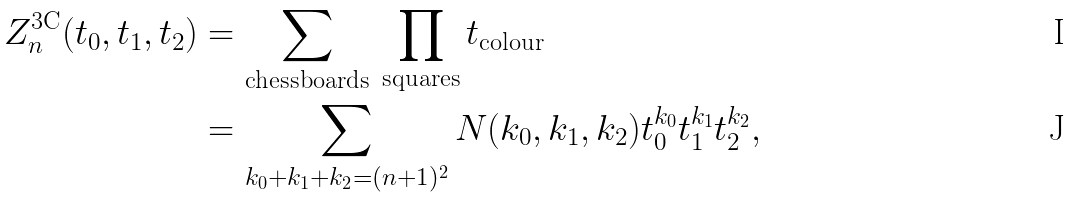<formula> <loc_0><loc_0><loc_500><loc_500>Z _ { n } ^ { \text {3C} } ( t _ { 0 } , t _ { 1 } , t _ { 2 } ) & = \sum _ { \text {chessboards} } \, \prod _ { \text {squares} } t _ { \text {colour} } \\ & = \sum _ { k _ { 0 } + k _ { 1 } + k _ { 2 } = ( n + 1 ) ^ { 2 } } N ( k _ { 0 } , k _ { 1 } , k _ { 2 } ) t _ { 0 } ^ { k _ { 0 } } t _ { 1 } ^ { k _ { 1 } } t _ { 2 } ^ { k _ { 2 } } ,</formula> 